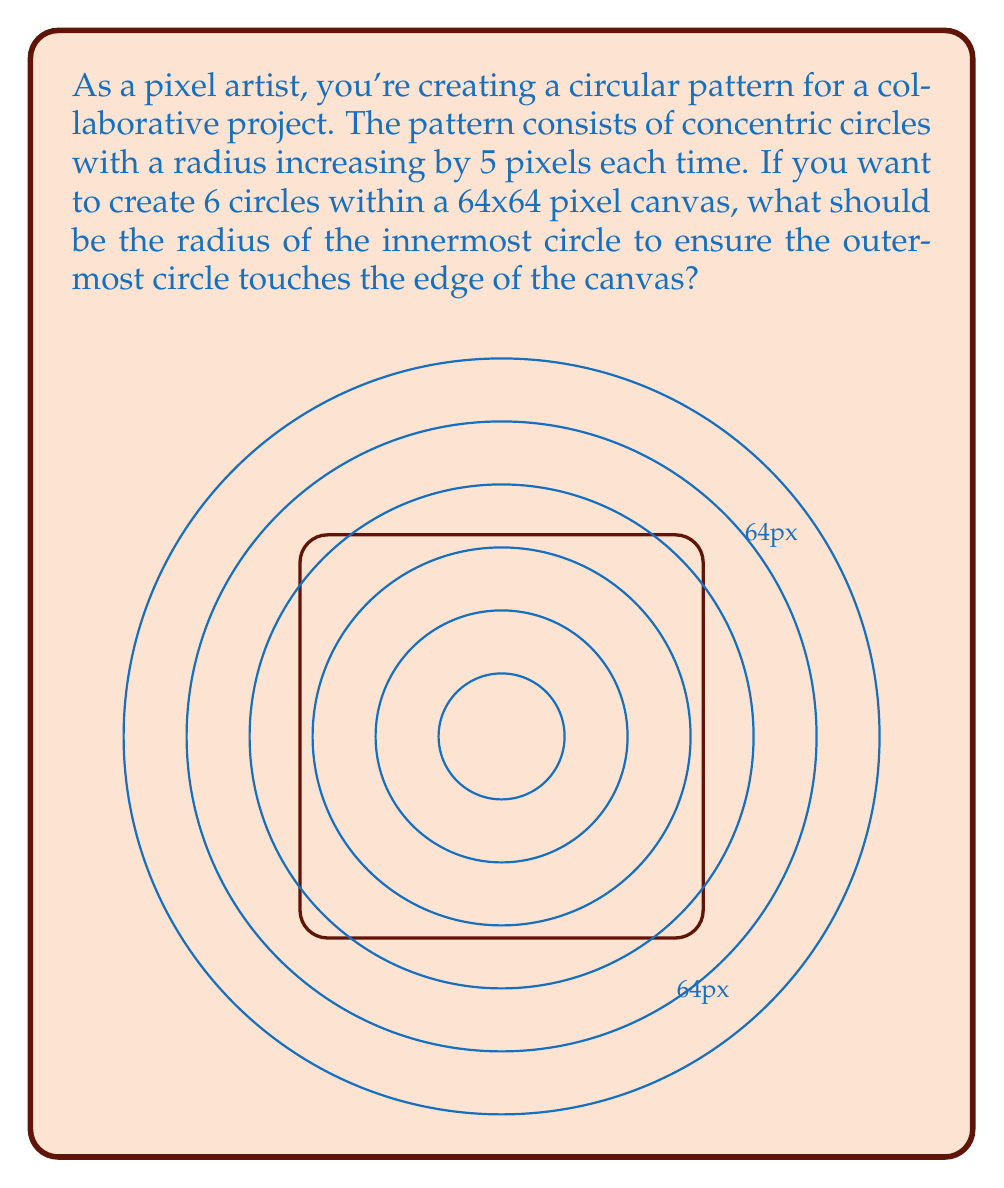Could you help me with this problem? Let's approach this step-by-step:

1) We know that the radius increases by 5 pixels for each circle, and we have 6 circles in total.

2) Let $r$ be the radius of the innermost circle. Then the radii of the circles will be:
   $r, r+5, r+10, r+15, r+20, r+25$

3) The outermost circle should touch the edge of the canvas. In a 64x64 pixel canvas, the radius of this circle should be 32 pixels (half of 64).

4) So we can write the equation:
   $r + 25 = 32$

5) Solving for $r$:
   $r = 32 - 25 = 7$

6) Let's verify:
   - Innermost circle: 7 pixels
   - Second circle: 12 pixels
   - Third circle: 17 pixels
   - Fourth circle: 22 pixels
   - Fifth circle: 27 pixels
   - Outermost circle: 32 pixels

7) The outermost circle indeed touches the edge of the 64x64 canvas, and we have 6 circles in total.

Therefore, the radius of the innermost circle should be 7 pixels.
Answer: 7 pixels 